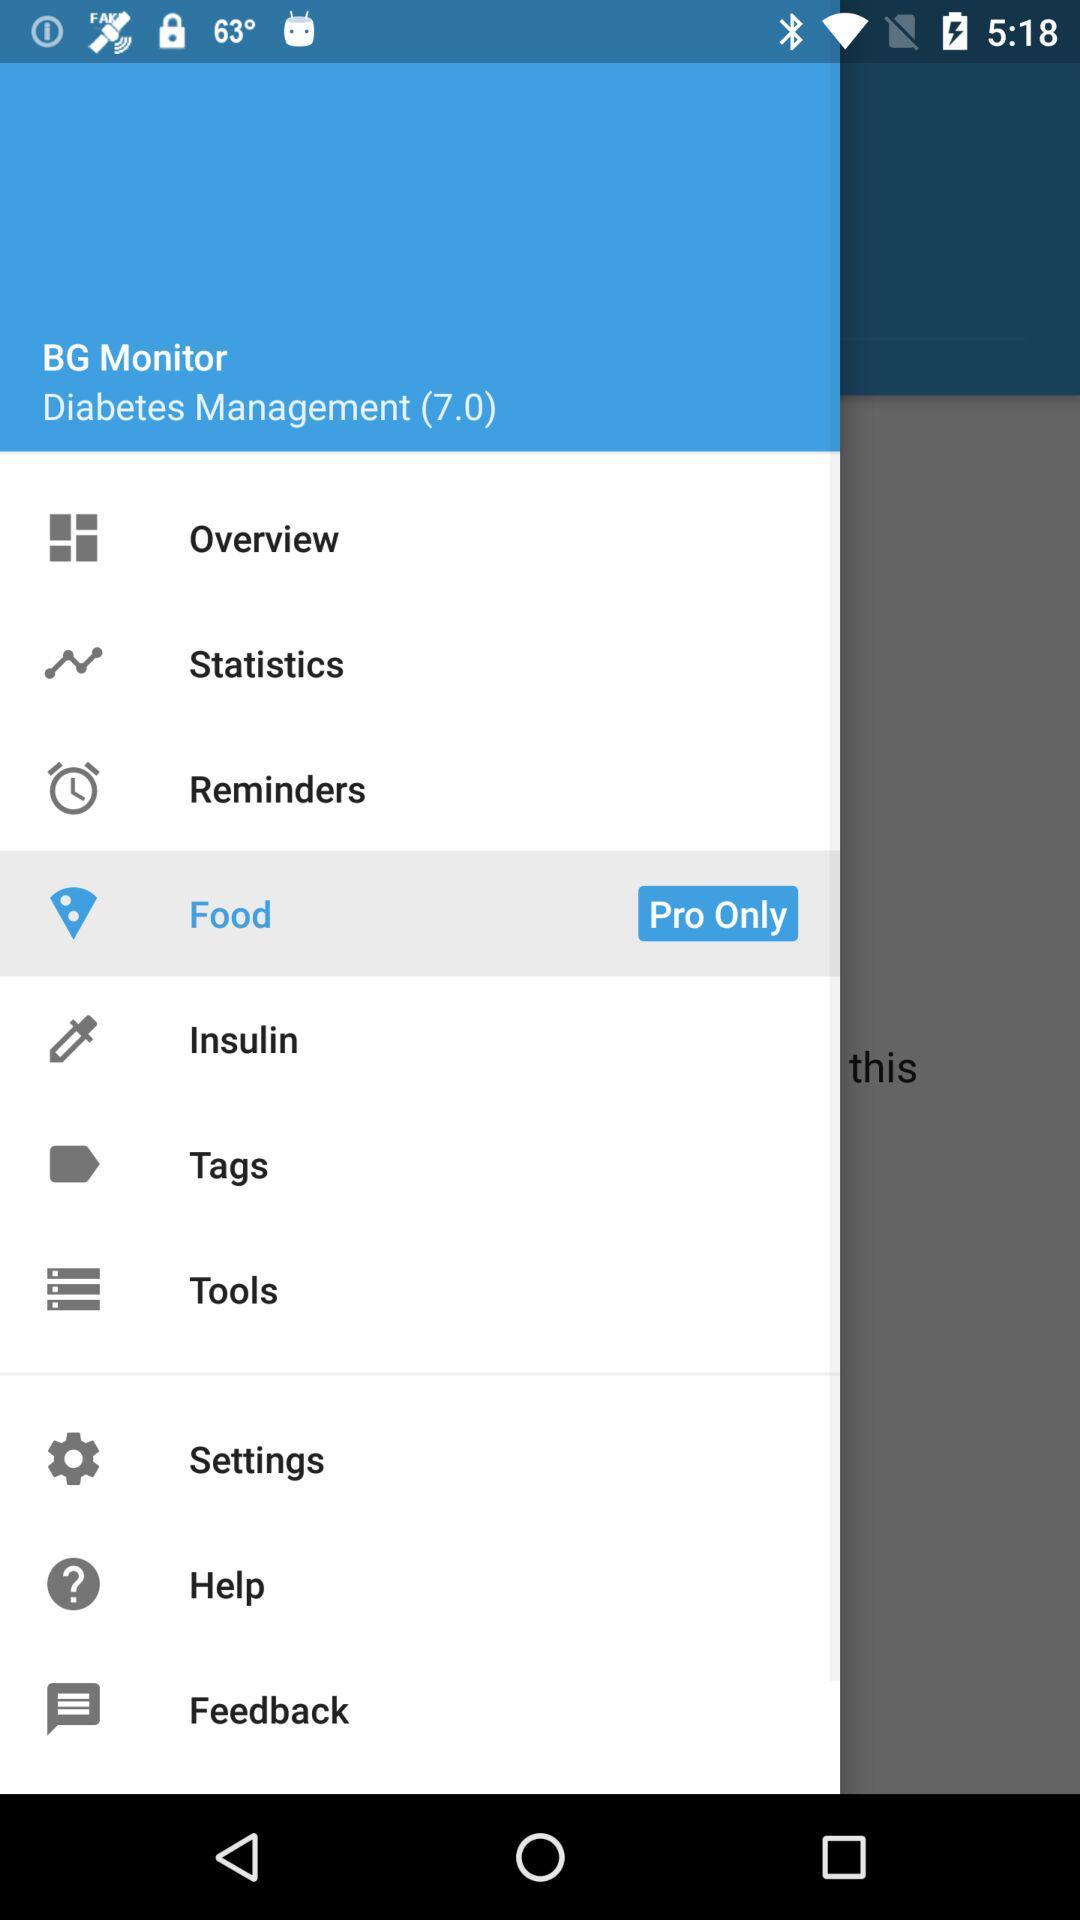Which item is selected? The selected item is "Food". 